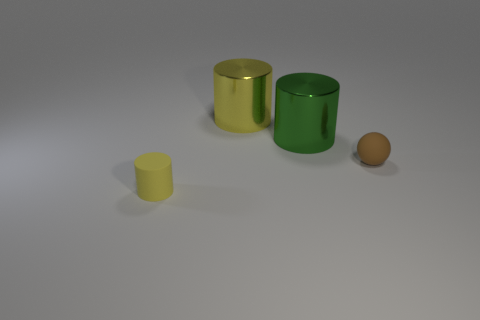Add 1 small rubber objects. How many objects exist? 5 Subtract all cylinders. How many objects are left? 1 Add 1 brown things. How many brown things exist? 2 Subtract 0 cyan spheres. How many objects are left? 4 Subtract all small rubber spheres. Subtract all metal cylinders. How many objects are left? 1 Add 2 big things. How many big things are left? 4 